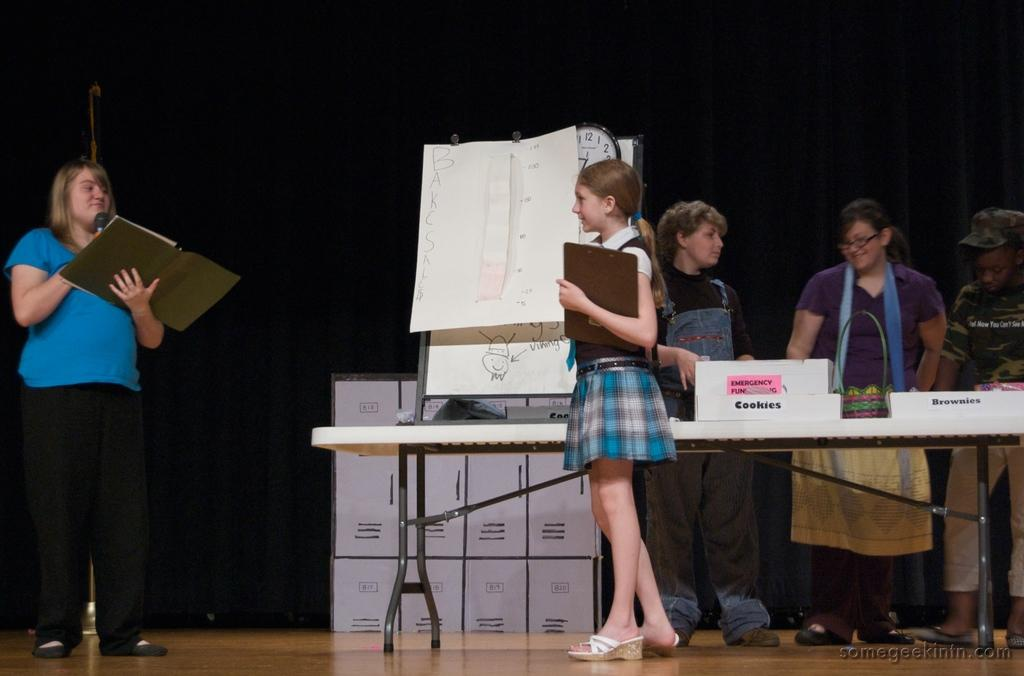How many people are standing near the table in the image? There are three persons standing near a table in the image. What is the person holding in the image? The person is holding a book and a microphone. What can be seen in the background of the image? There are cupboards and a hoarding in the background. What type of vacation is being advertised on the cup in the image? There is no cup present in the image, so it is not possible to determine what type of vacation might be advertised. 